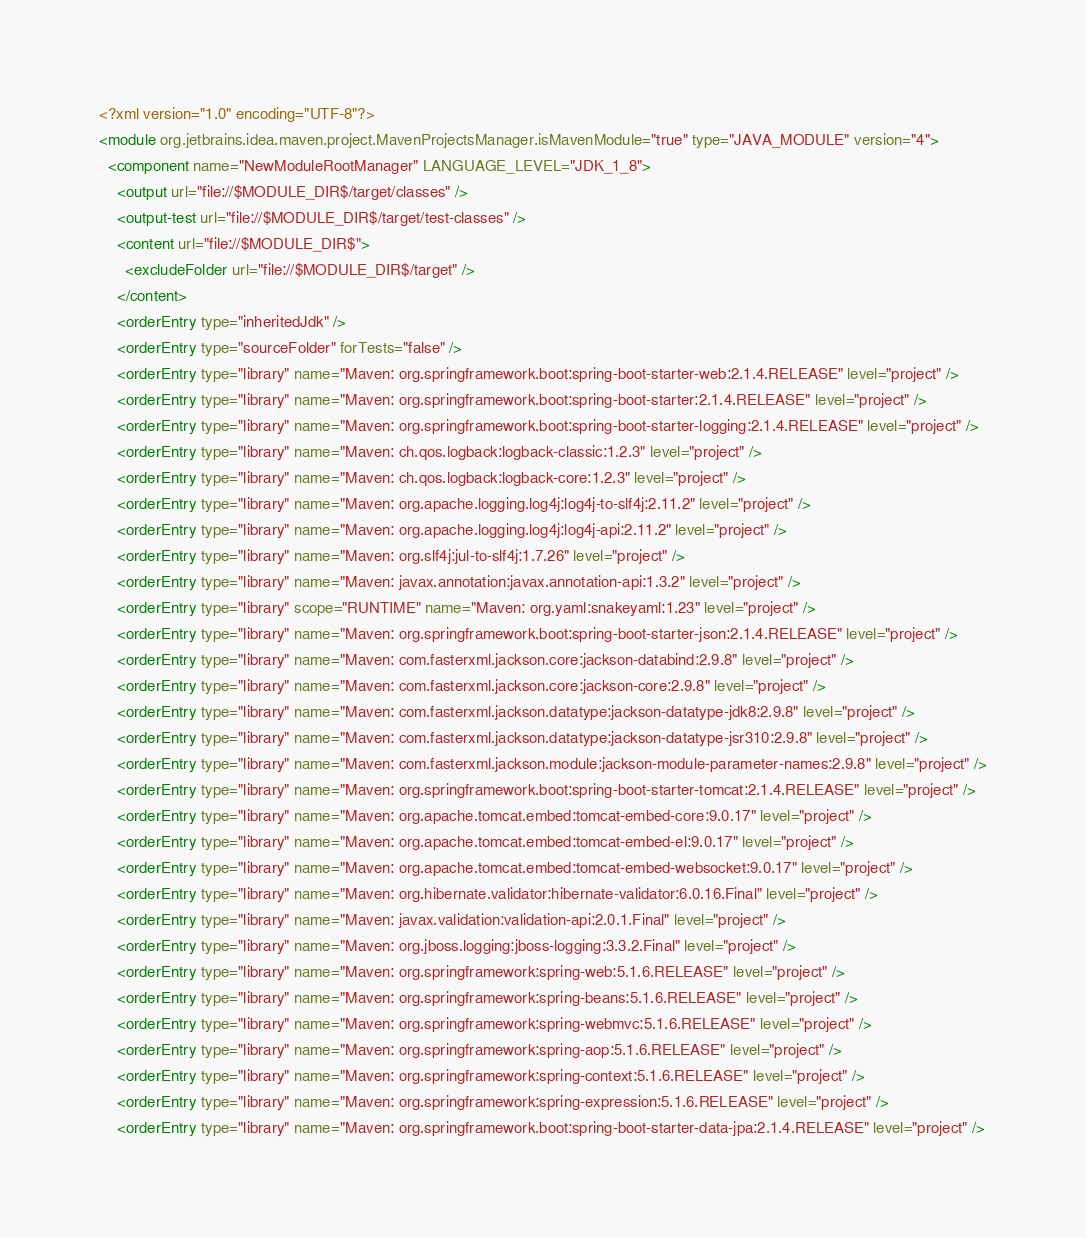<code> <loc_0><loc_0><loc_500><loc_500><_XML_><?xml version="1.0" encoding="UTF-8"?>
<module org.jetbrains.idea.maven.project.MavenProjectsManager.isMavenModule="true" type="JAVA_MODULE" version="4">
  <component name="NewModuleRootManager" LANGUAGE_LEVEL="JDK_1_8">
    <output url="file://$MODULE_DIR$/target/classes" />
    <output-test url="file://$MODULE_DIR$/target/test-classes" />
    <content url="file://$MODULE_DIR$">
      <excludeFolder url="file://$MODULE_DIR$/target" />
    </content>
    <orderEntry type="inheritedJdk" />
    <orderEntry type="sourceFolder" forTests="false" />
    <orderEntry type="library" name="Maven: org.springframework.boot:spring-boot-starter-web:2.1.4.RELEASE" level="project" />
    <orderEntry type="library" name="Maven: org.springframework.boot:spring-boot-starter:2.1.4.RELEASE" level="project" />
    <orderEntry type="library" name="Maven: org.springframework.boot:spring-boot-starter-logging:2.1.4.RELEASE" level="project" />
    <orderEntry type="library" name="Maven: ch.qos.logback:logback-classic:1.2.3" level="project" />
    <orderEntry type="library" name="Maven: ch.qos.logback:logback-core:1.2.3" level="project" />
    <orderEntry type="library" name="Maven: org.apache.logging.log4j:log4j-to-slf4j:2.11.2" level="project" />
    <orderEntry type="library" name="Maven: org.apache.logging.log4j:log4j-api:2.11.2" level="project" />
    <orderEntry type="library" name="Maven: org.slf4j:jul-to-slf4j:1.7.26" level="project" />
    <orderEntry type="library" name="Maven: javax.annotation:javax.annotation-api:1.3.2" level="project" />
    <orderEntry type="library" scope="RUNTIME" name="Maven: org.yaml:snakeyaml:1.23" level="project" />
    <orderEntry type="library" name="Maven: org.springframework.boot:spring-boot-starter-json:2.1.4.RELEASE" level="project" />
    <orderEntry type="library" name="Maven: com.fasterxml.jackson.core:jackson-databind:2.9.8" level="project" />
    <orderEntry type="library" name="Maven: com.fasterxml.jackson.core:jackson-core:2.9.8" level="project" />
    <orderEntry type="library" name="Maven: com.fasterxml.jackson.datatype:jackson-datatype-jdk8:2.9.8" level="project" />
    <orderEntry type="library" name="Maven: com.fasterxml.jackson.datatype:jackson-datatype-jsr310:2.9.8" level="project" />
    <orderEntry type="library" name="Maven: com.fasterxml.jackson.module:jackson-module-parameter-names:2.9.8" level="project" />
    <orderEntry type="library" name="Maven: org.springframework.boot:spring-boot-starter-tomcat:2.1.4.RELEASE" level="project" />
    <orderEntry type="library" name="Maven: org.apache.tomcat.embed:tomcat-embed-core:9.0.17" level="project" />
    <orderEntry type="library" name="Maven: org.apache.tomcat.embed:tomcat-embed-el:9.0.17" level="project" />
    <orderEntry type="library" name="Maven: org.apache.tomcat.embed:tomcat-embed-websocket:9.0.17" level="project" />
    <orderEntry type="library" name="Maven: org.hibernate.validator:hibernate-validator:6.0.16.Final" level="project" />
    <orderEntry type="library" name="Maven: javax.validation:validation-api:2.0.1.Final" level="project" />
    <orderEntry type="library" name="Maven: org.jboss.logging:jboss-logging:3.3.2.Final" level="project" />
    <orderEntry type="library" name="Maven: org.springframework:spring-web:5.1.6.RELEASE" level="project" />
    <orderEntry type="library" name="Maven: org.springframework:spring-beans:5.1.6.RELEASE" level="project" />
    <orderEntry type="library" name="Maven: org.springframework:spring-webmvc:5.1.6.RELEASE" level="project" />
    <orderEntry type="library" name="Maven: org.springframework:spring-aop:5.1.6.RELEASE" level="project" />
    <orderEntry type="library" name="Maven: org.springframework:spring-context:5.1.6.RELEASE" level="project" />
    <orderEntry type="library" name="Maven: org.springframework:spring-expression:5.1.6.RELEASE" level="project" />
    <orderEntry type="library" name="Maven: org.springframework.boot:spring-boot-starter-data-jpa:2.1.4.RELEASE" level="project" /></code> 